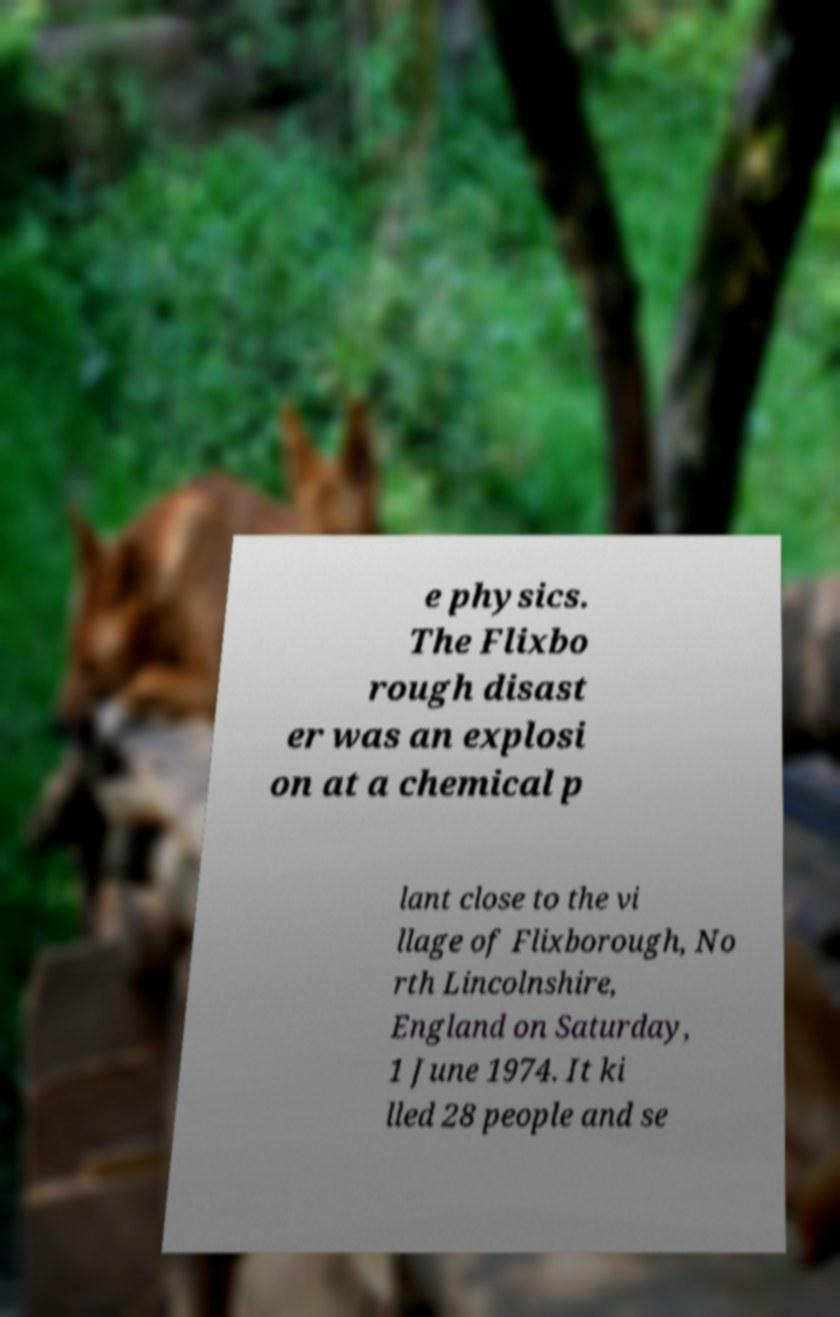There's text embedded in this image that I need extracted. Can you transcribe it verbatim? e physics. The Flixbo rough disast er was an explosi on at a chemical p lant close to the vi llage of Flixborough, No rth Lincolnshire, England on Saturday, 1 June 1974. It ki lled 28 people and se 